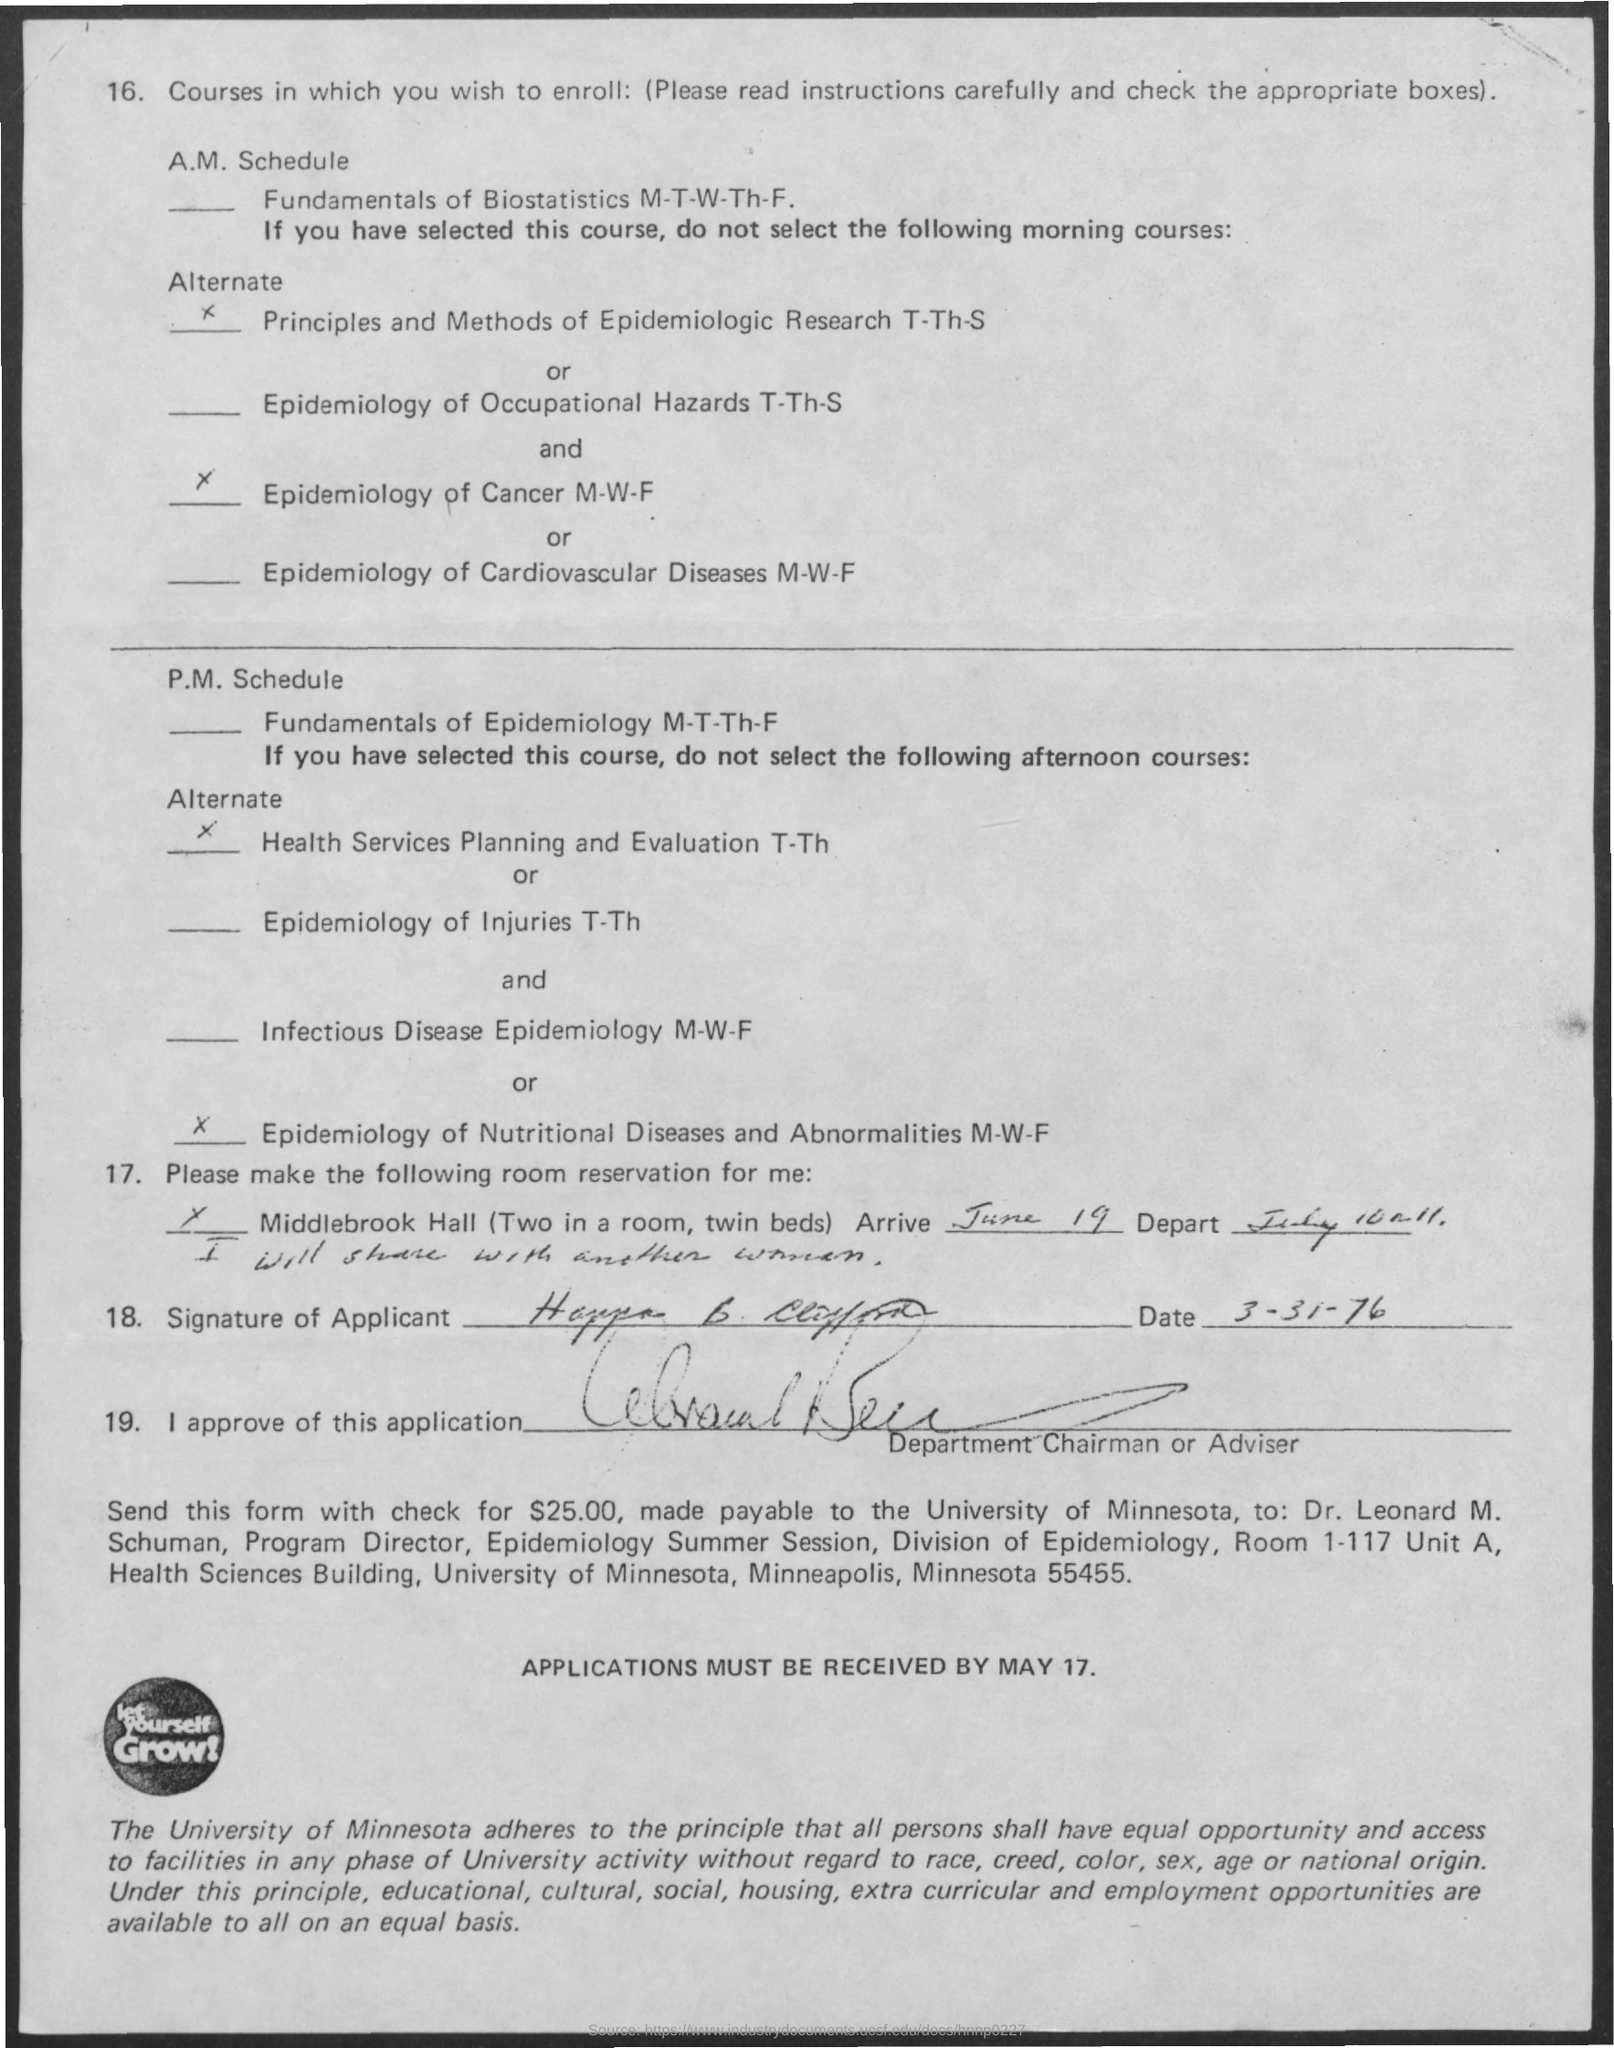What is written in the logo in the bottom of the document?
Ensure brevity in your answer.  Let Yourself Grow!. APPLICATIONS must be received by which date?
Offer a very short reply. MAY 17. What is the name of the university mentioned in the last paragraph?
Provide a short and direct response. University of Minnesota. What is the date the applicant signed the application?
Keep it short and to the point. 3-31-76. 